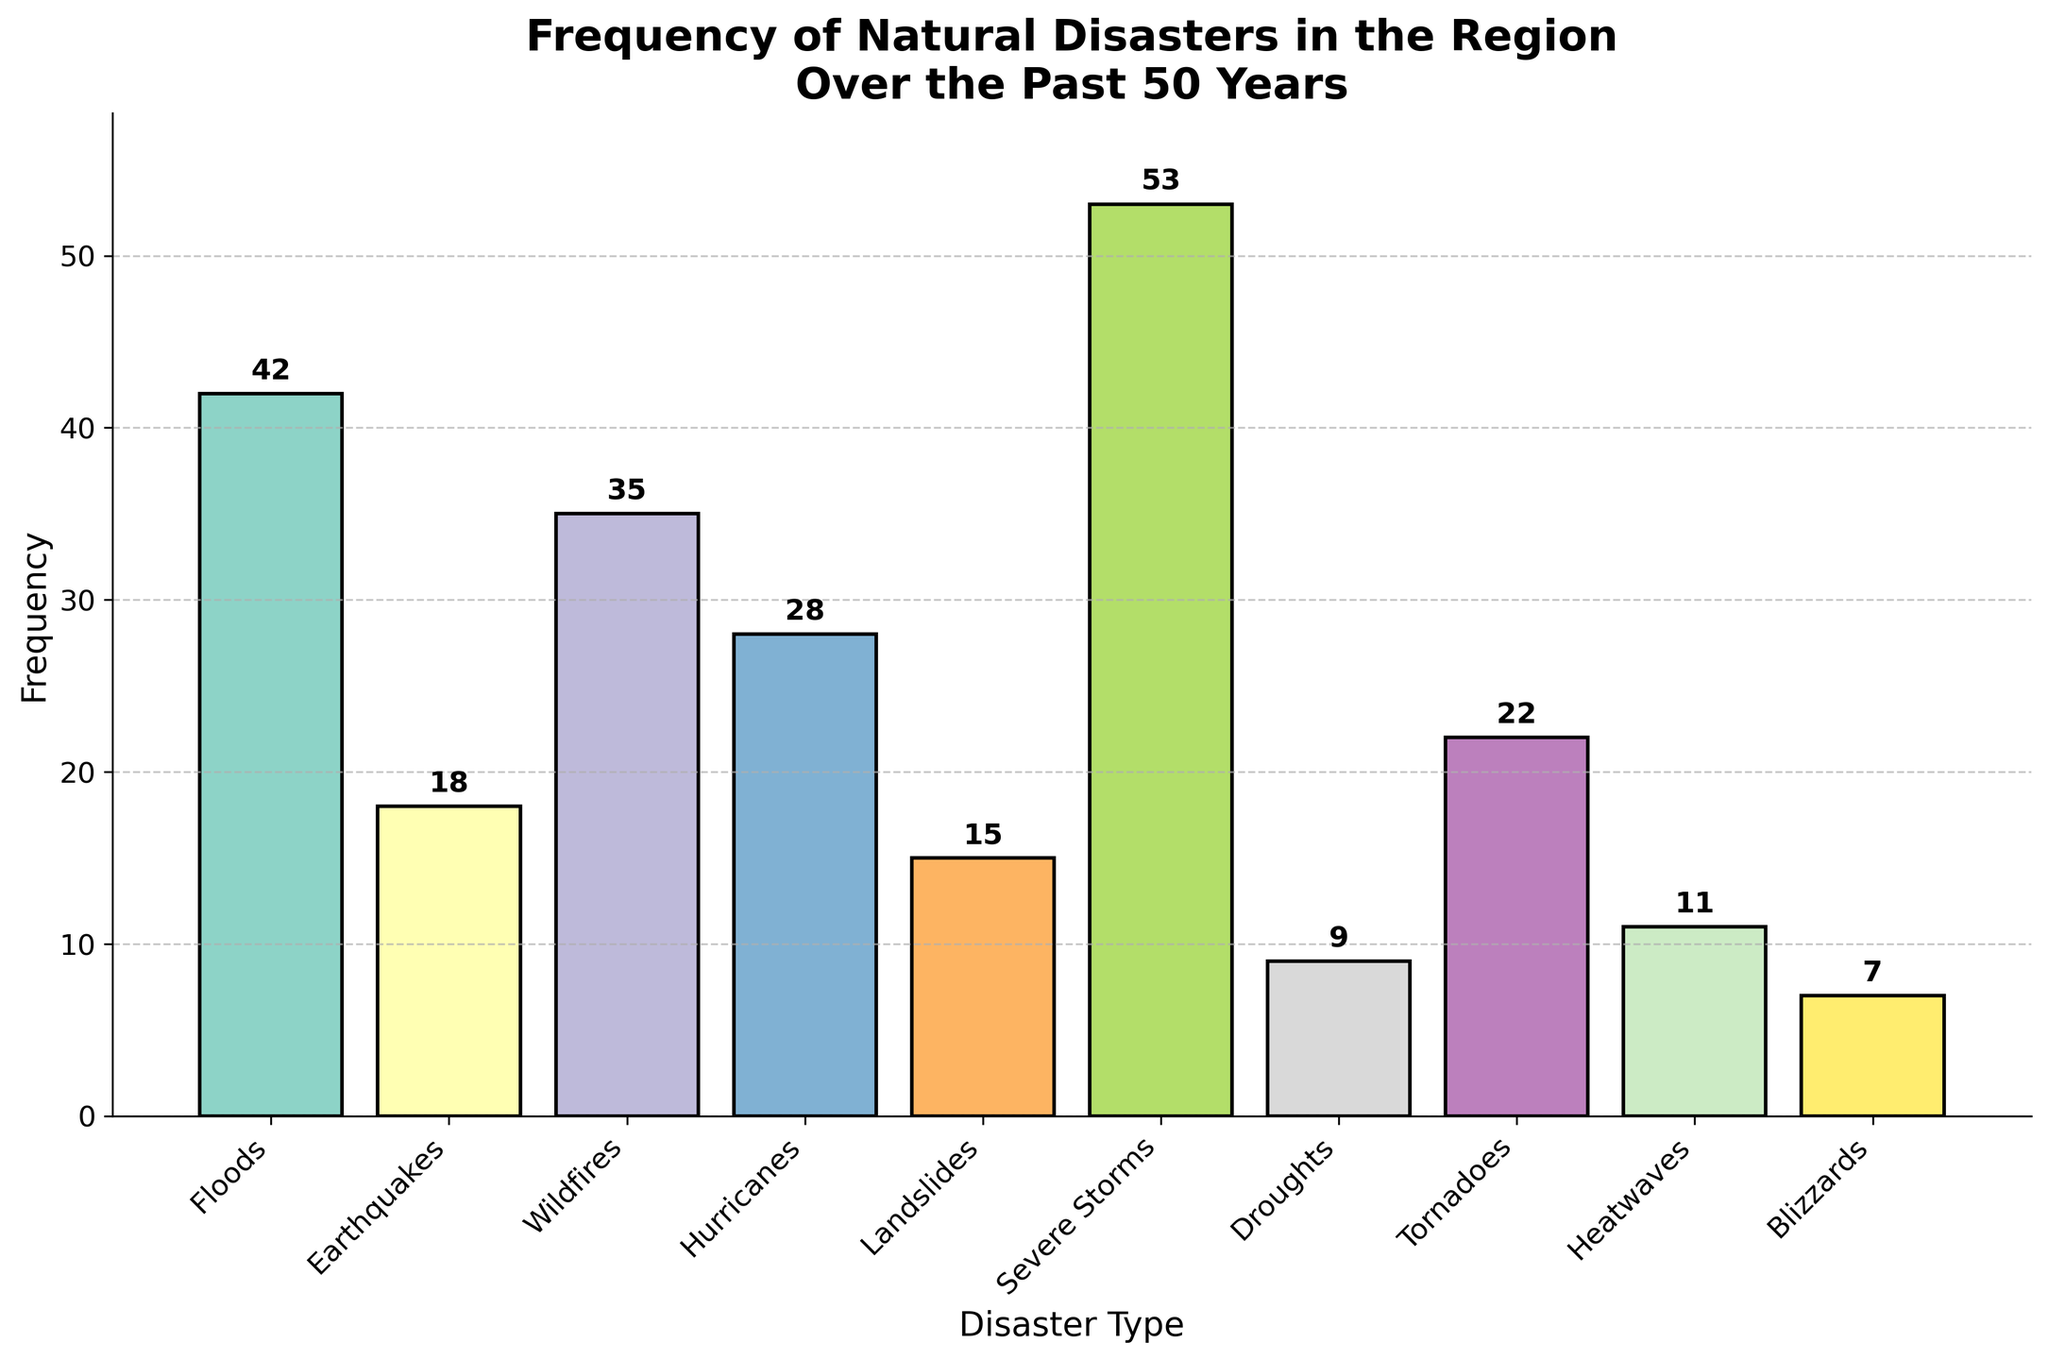What is the title of the plot? The title of the plot is displayed at the top and often provides a brief description of what the plot represents. In this case, it tells us the subject of our data visualization.
Answer: Frequency of Natural Disasters in the Region Over the Past 50 Years Which disaster type has the highest frequency? Look at the bars representing the frequency of each disaster type, the highest bar corresponds to the disaster with the highest frequency.
Answer: Severe Storms What is the frequency of wildfires? Find the bar corresponding to wildfires on the x-axis and check its height. The text above it also provides the exact number.
Answer: 35 How many types of natural disasters are represented in the plot? Count the number of bars shown on the x-axis, each representing a different type of disaster.
Answer: 10 Which disaster type has a lower frequency than earthquakes but higher than heatwaves? On the x-axis, locate the bars for Earthquakes and Heatwaves. Then determine which bar falls between these two frequencies.
Answer: Tornadoes What's the sum of the frequencies of Floods and Hurricanes? Find the heights of the bars for Floods and Hurricanes, then add these two values. Floods have a frequency of 42 and Hurricanes have a frequency of 28. Adding them together: 42 + 28.
Answer: 70 What is the average frequency of the top three most frequent disaster types? Identify the three disaster types with the highest frequencies, sum their frequencies, and then divide by three. The top three are Severe Storms (53), Floods (42), and Wildfires (35). Their total is 53 + 42 + 35 = 130. Divide this by 3 to get the average: 130 / 3.
Answer: 43.33 Which disaster type has the smallest frequency? Locate the shortest bar on the plot, which corresponds to the disaster type with the smallest frequency.
Answer: Blizzards How many disaster types have a frequency greater than 25? Count the number of bars that extend higher than the 25 mark on the y-axis. These represent disaster types with a frequency greater than 25.
Answer: 5 Compare the frequency of Tornadoes to that of Earthquakes. Which one is more frequent? Look at the bars corresponding to Tornadoes and Earthquakes and compare their heights. Tornadoes have a higher bar than Earthquakes.
Answer: Tornadoes 